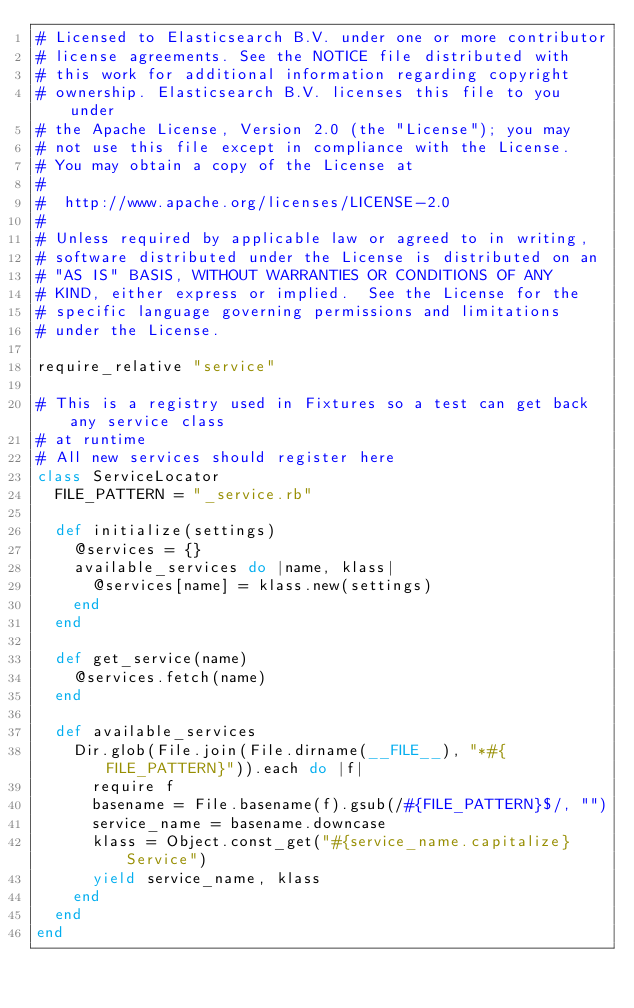Convert code to text. <code><loc_0><loc_0><loc_500><loc_500><_Ruby_># Licensed to Elasticsearch B.V. under one or more contributor
# license agreements. See the NOTICE file distributed with
# this work for additional information regarding copyright
# ownership. Elasticsearch B.V. licenses this file to you under
# the Apache License, Version 2.0 (the "License"); you may
# not use this file except in compliance with the License.
# You may obtain a copy of the License at
#
#  http://www.apache.org/licenses/LICENSE-2.0
#
# Unless required by applicable law or agreed to in writing,
# software distributed under the License is distributed on an
# "AS IS" BASIS, WITHOUT WARRANTIES OR CONDITIONS OF ANY
# KIND, either express or implied.  See the License for the
# specific language governing permissions and limitations
# under the License.

require_relative "service"

# This is a registry used in Fixtures so a test can get back any service class
# at runtime
# All new services should register here
class ServiceLocator
  FILE_PATTERN = "_service.rb"

  def initialize(settings)
    @services = {}
    available_services do |name, klass|
      @services[name] = klass.new(settings)
    end
  end

  def get_service(name)
    @services.fetch(name)
  end

  def available_services
    Dir.glob(File.join(File.dirname(__FILE__), "*#{FILE_PATTERN}")).each do |f|
      require f
      basename = File.basename(f).gsub(/#{FILE_PATTERN}$/, "")
      service_name = basename.downcase
      klass = Object.const_get("#{service_name.capitalize}Service")
      yield service_name, klass
    end
  end
end
</code> 